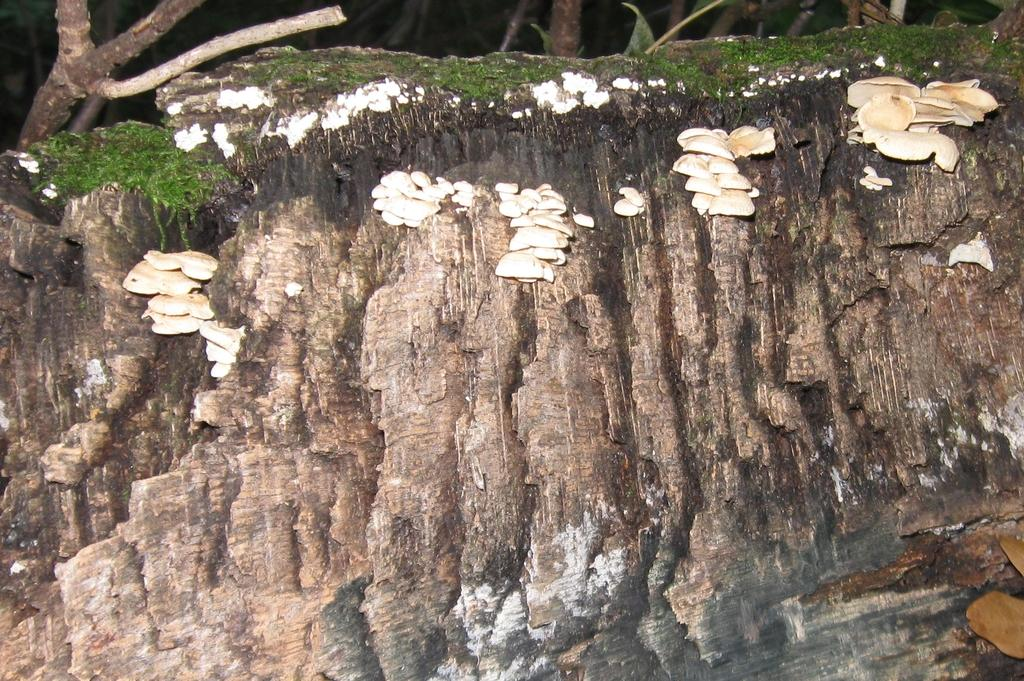What type of fungi can be seen on a wall in the image? There are mushrooms on a wall in the image. What type of vegetation is visible in the background of the image? There are trees in the background of the image. What type of game is being played on the wall in the image? There is no game being played on the wall in the image; it features mushrooms. What type of insurance policy is being advertised on the wall in the image? There is no insurance policy being advertised on the wall in the image; it features mushrooms. 